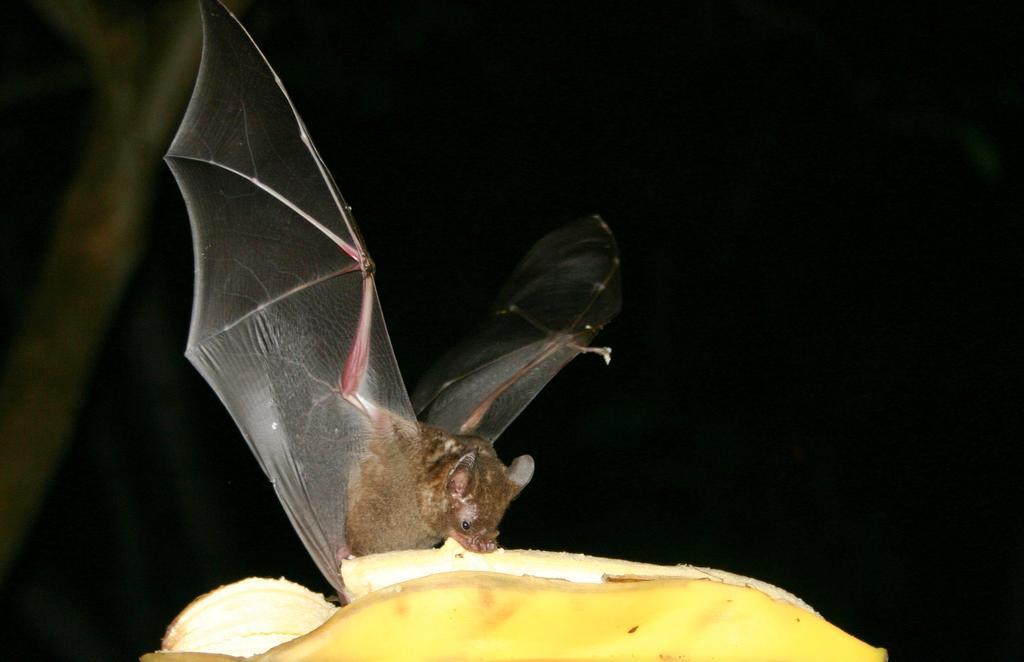Please provide a concise description of this image. In this image we can see a bat sitting on the banana. 